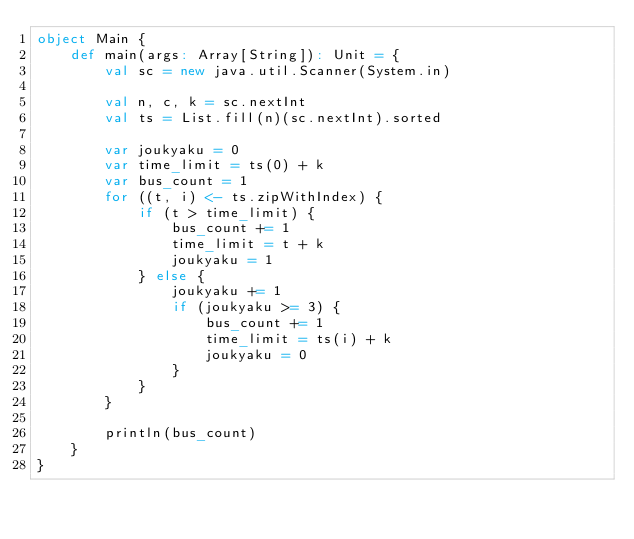<code> <loc_0><loc_0><loc_500><loc_500><_Scala_>object Main {
    def main(args: Array[String]): Unit = {
        val sc = new java.util.Scanner(System.in)
        
        val n, c, k = sc.nextInt
        val ts = List.fill(n)(sc.nextInt).sorted
        
        var joukyaku = 0
        var time_limit = ts(0) + k
        var bus_count = 1
        for ((t, i) <- ts.zipWithIndex) {
            if (t > time_limit) {
                bus_count += 1
                time_limit = t + k
                joukyaku = 1
            } else {
                joukyaku += 1
                if (joukyaku >= 3) {
                    bus_count += 1
                    time_limit = ts(i) + k
                    joukyaku = 0
                }
            }
        }
        
        println(bus_count)
    }
}</code> 